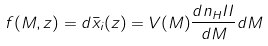<formula> <loc_0><loc_0><loc_500><loc_500>f ( M , z ) = d \bar { x } _ { i } ( z ) = V ( M ) \frac { d n _ { H } I I } { d M } d M</formula> 